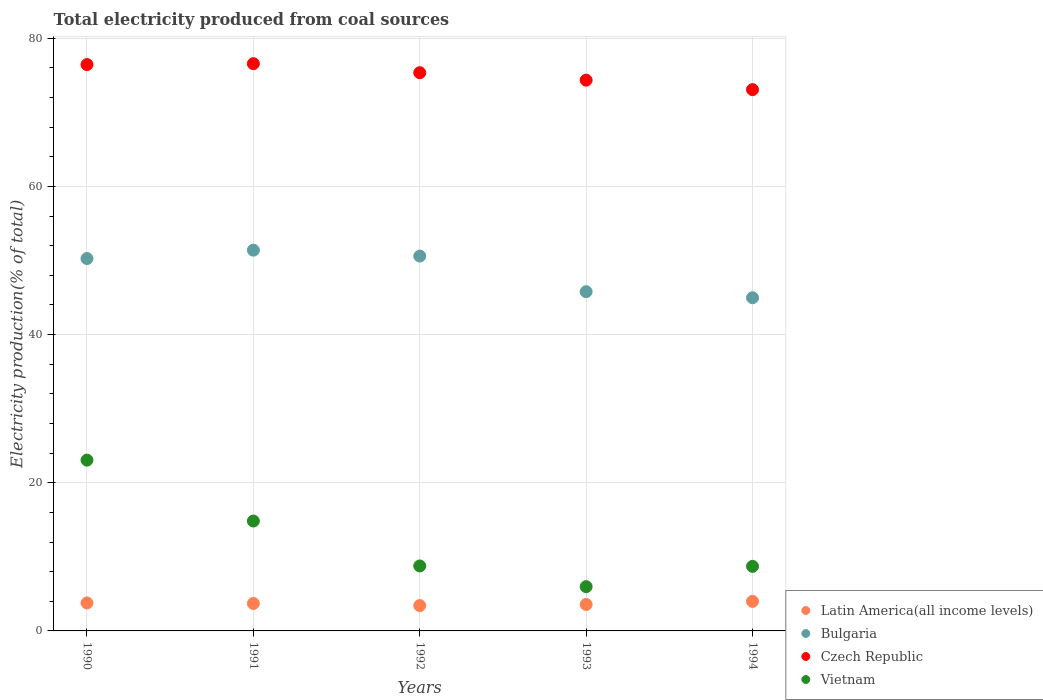What is the total electricity produced in Bulgaria in 1991?
Offer a very short reply. 51.39. Across all years, what is the maximum total electricity produced in Latin America(all income levels)?
Make the answer very short. 3.99. Across all years, what is the minimum total electricity produced in Bulgaria?
Provide a succinct answer. 44.97. In which year was the total electricity produced in Latin America(all income levels) maximum?
Provide a succinct answer. 1994. In which year was the total electricity produced in Bulgaria minimum?
Make the answer very short. 1994. What is the total total electricity produced in Vietnam in the graph?
Give a very brief answer. 61.34. What is the difference between the total electricity produced in Bulgaria in 1990 and that in 1993?
Your response must be concise. 4.47. What is the difference between the total electricity produced in Latin America(all income levels) in 1994 and the total electricity produced in Czech Republic in 1992?
Your answer should be very brief. -71.35. What is the average total electricity produced in Latin America(all income levels) per year?
Your response must be concise. 3.69. In the year 1993, what is the difference between the total electricity produced in Latin America(all income levels) and total electricity produced in Czech Republic?
Keep it short and to the point. -70.77. What is the ratio of the total electricity produced in Latin America(all income levels) in 1990 to that in 1991?
Offer a terse response. 1.02. Is the total electricity produced in Latin America(all income levels) in 1993 less than that in 1994?
Make the answer very short. Yes. Is the difference between the total electricity produced in Latin America(all income levels) in 1990 and 1991 greater than the difference between the total electricity produced in Czech Republic in 1990 and 1991?
Ensure brevity in your answer.  Yes. What is the difference between the highest and the second highest total electricity produced in Vietnam?
Provide a succinct answer. 8.22. What is the difference between the highest and the lowest total electricity produced in Czech Republic?
Offer a terse response. 3.5. Is the sum of the total electricity produced in Bulgaria in 1990 and 1991 greater than the maximum total electricity produced in Latin America(all income levels) across all years?
Offer a very short reply. Yes. How many years are there in the graph?
Your answer should be very brief. 5. Are the values on the major ticks of Y-axis written in scientific E-notation?
Provide a succinct answer. No. What is the title of the graph?
Your answer should be very brief. Total electricity produced from coal sources. What is the label or title of the X-axis?
Provide a succinct answer. Years. What is the label or title of the Y-axis?
Provide a short and direct response. Electricity production(% of total). What is the Electricity production(% of total) in Latin America(all income levels) in 1990?
Provide a succinct answer. 3.78. What is the Electricity production(% of total) in Bulgaria in 1990?
Keep it short and to the point. 50.26. What is the Electricity production(% of total) in Czech Republic in 1990?
Make the answer very short. 76.44. What is the Electricity production(% of total) in Vietnam in 1990?
Your answer should be compact. 23.05. What is the Electricity production(% of total) in Latin America(all income levels) in 1991?
Offer a terse response. 3.7. What is the Electricity production(% of total) of Bulgaria in 1991?
Your response must be concise. 51.39. What is the Electricity production(% of total) of Czech Republic in 1991?
Provide a short and direct response. 76.56. What is the Electricity production(% of total) in Vietnam in 1991?
Offer a terse response. 14.83. What is the Electricity production(% of total) in Latin America(all income levels) in 1992?
Give a very brief answer. 3.42. What is the Electricity production(% of total) in Bulgaria in 1992?
Give a very brief answer. 50.59. What is the Electricity production(% of total) in Czech Republic in 1992?
Your answer should be compact. 75.34. What is the Electricity production(% of total) in Vietnam in 1992?
Make the answer very short. 8.77. What is the Electricity production(% of total) of Latin America(all income levels) in 1993?
Provide a succinct answer. 3.57. What is the Electricity production(% of total) in Bulgaria in 1993?
Your answer should be very brief. 45.79. What is the Electricity production(% of total) in Czech Republic in 1993?
Provide a short and direct response. 74.34. What is the Electricity production(% of total) in Vietnam in 1993?
Offer a very short reply. 5.97. What is the Electricity production(% of total) of Latin America(all income levels) in 1994?
Your answer should be compact. 3.99. What is the Electricity production(% of total) of Bulgaria in 1994?
Your response must be concise. 44.97. What is the Electricity production(% of total) of Czech Republic in 1994?
Your answer should be very brief. 73.06. What is the Electricity production(% of total) of Vietnam in 1994?
Keep it short and to the point. 8.72. Across all years, what is the maximum Electricity production(% of total) of Latin America(all income levels)?
Offer a very short reply. 3.99. Across all years, what is the maximum Electricity production(% of total) of Bulgaria?
Ensure brevity in your answer.  51.39. Across all years, what is the maximum Electricity production(% of total) in Czech Republic?
Provide a short and direct response. 76.56. Across all years, what is the maximum Electricity production(% of total) in Vietnam?
Keep it short and to the point. 23.05. Across all years, what is the minimum Electricity production(% of total) in Latin America(all income levels)?
Offer a very short reply. 3.42. Across all years, what is the minimum Electricity production(% of total) in Bulgaria?
Ensure brevity in your answer.  44.97. Across all years, what is the minimum Electricity production(% of total) of Czech Republic?
Ensure brevity in your answer.  73.06. Across all years, what is the minimum Electricity production(% of total) of Vietnam?
Ensure brevity in your answer.  5.97. What is the total Electricity production(% of total) of Latin America(all income levels) in the graph?
Your answer should be very brief. 18.46. What is the total Electricity production(% of total) in Bulgaria in the graph?
Offer a terse response. 243. What is the total Electricity production(% of total) in Czech Republic in the graph?
Keep it short and to the point. 375.74. What is the total Electricity production(% of total) of Vietnam in the graph?
Offer a terse response. 61.34. What is the difference between the Electricity production(% of total) in Latin America(all income levels) in 1990 and that in 1991?
Provide a succinct answer. 0.07. What is the difference between the Electricity production(% of total) of Bulgaria in 1990 and that in 1991?
Your answer should be very brief. -1.13. What is the difference between the Electricity production(% of total) in Czech Republic in 1990 and that in 1991?
Your response must be concise. -0.12. What is the difference between the Electricity production(% of total) of Vietnam in 1990 and that in 1991?
Provide a short and direct response. 8.22. What is the difference between the Electricity production(% of total) of Latin America(all income levels) in 1990 and that in 1992?
Keep it short and to the point. 0.36. What is the difference between the Electricity production(% of total) of Bulgaria in 1990 and that in 1992?
Your response must be concise. -0.33. What is the difference between the Electricity production(% of total) of Czech Republic in 1990 and that in 1992?
Ensure brevity in your answer.  1.1. What is the difference between the Electricity production(% of total) of Vietnam in 1990 and that in 1992?
Your response must be concise. 14.28. What is the difference between the Electricity production(% of total) in Latin America(all income levels) in 1990 and that in 1993?
Your response must be concise. 0.2. What is the difference between the Electricity production(% of total) of Bulgaria in 1990 and that in 1993?
Keep it short and to the point. 4.47. What is the difference between the Electricity production(% of total) of Czech Republic in 1990 and that in 1993?
Keep it short and to the point. 2.1. What is the difference between the Electricity production(% of total) of Vietnam in 1990 and that in 1993?
Provide a succinct answer. 17.08. What is the difference between the Electricity production(% of total) of Latin America(all income levels) in 1990 and that in 1994?
Your answer should be very brief. -0.21. What is the difference between the Electricity production(% of total) of Bulgaria in 1990 and that in 1994?
Make the answer very short. 5.29. What is the difference between the Electricity production(% of total) of Czech Republic in 1990 and that in 1994?
Give a very brief answer. 3.38. What is the difference between the Electricity production(% of total) of Vietnam in 1990 and that in 1994?
Make the answer very short. 14.33. What is the difference between the Electricity production(% of total) in Latin America(all income levels) in 1991 and that in 1992?
Provide a short and direct response. 0.28. What is the difference between the Electricity production(% of total) of Bulgaria in 1991 and that in 1992?
Give a very brief answer. 0.8. What is the difference between the Electricity production(% of total) of Czech Republic in 1991 and that in 1992?
Your response must be concise. 1.22. What is the difference between the Electricity production(% of total) in Vietnam in 1991 and that in 1992?
Your answer should be very brief. 6.06. What is the difference between the Electricity production(% of total) of Latin America(all income levels) in 1991 and that in 1993?
Make the answer very short. 0.13. What is the difference between the Electricity production(% of total) of Bulgaria in 1991 and that in 1993?
Provide a succinct answer. 5.6. What is the difference between the Electricity production(% of total) in Czech Republic in 1991 and that in 1993?
Your answer should be very brief. 2.22. What is the difference between the Electricity production(% of total) of Vietnam in 1991 and that in 1993?
Your answer should be very brief. 8.86. What is the difference between the Electricity production(% of total) in Latin America(all income levels) in 1991 and that in 1994?
Provide a succinct answer. -0.29. What is the difference between the Electricity production(% of total) of Bulgaria in 1991 and that in 1994?
Give a very brief answer. 6.42. What is the difference between the Electricity production(% of total) of Czech Republic in 1991 and that in 1994?
Give a very brief answer. 3.5. What is the difference between the Electricity production(% of total) in Vietnam in 1991 and that in 1994?
Your response must be concise. 6.12. What is the difference between the Electricity production(% of total) of Latin America(all income levels) in 1992 and that in 1993?
Your response must be concise. -0.15. What is the difference between the Electricity production(% of total) of Bulgaria in 1992 and that in 1993?
Ensure brevity in your answer.  4.8. What is the difference between the Electricity production(% of total) of Czech Republic in 1992 and that in 1993?
Give a very brief answer. 1. What is the difference between the Electricity production(% of total) in Vietnam in 1992 and that in 1993?
Provide a succinct answer. 2.79. What is the difference between the Electricity production(% of total) in Latin America(all income levels) in 1992 and that in 1994?
Ensure brevity in your answer.  -0.57. What is the difference between the Electricity production(% of total) in Bulgaria in 1992 and that in 1994?
Make the answer very short. 5.62. What is the difference between the Electricity production(% of total) in Czech Republic in 1992 and that in 1994?
Give a very brief answer. 2.28. What is the difference between the Electricity production(% of total) of Vietnam in 1992 and that in 1994?
Give a very brief answer. 0.05. What is the difference between the Electricity production(% of total) of Latin America(all income levels) in 1993 and that in 1994?
Make the answer very short. -0.42. What is the difference between the Electricity production(% of total) in Bulgaria in 1993 and that in 1994?
Provide a short and direct response. 0.82. What is the difference between the Electricity production(% of total) in Czech Republic in 1993 and that in 1994?
Make the answer very short. 1.28. What is the difference between the Electricity production(% of total) in Vietnam in 1993 and that in 1994?
Offer a very short reply. -2.74. What is the difference between the Electricity production(% of total) of Latin America(all income levels) in 1990 and the Electricity production(% of total) of Bulgaria in 1991?
Provide a short and direct response. -47.62. What is the difference between the Electricity production(% of total) of Latin America(all income levels) in 1990 and the Electricity production(% of total) of Czech Republic in 1991?
Offer a terse response. -72.79. What is the difference between the Electricity production(% of total) in Latin America(all income levels) in 1990 and the Electricity production(% of total) in Vietnam in 1991?
Offer a terse response. -11.06. What is the difference between the Electricity production(% of total) in Bulgaria in 1990 and the Electricity production(% of total) in Czech Republic in 1991?
Offer a terse response. -26.3. What is the difference between the Electricity production(% of total) in Bulgaria in 1990 and the Electricity production(% of total) in Vietnam in 1991?
Provide a succinct answer. 35.43. What is the difference between the Electricity production(% of total) in Czech Republic in 1990 and the Electricity production(% of total) in Vietnam in 1991?
Your response must be concise. 61.61. What is the difference between the Electricity production(% of total) in Latin America(all income levels) in 1990 and the Electricity production(% of total) in Bulgaria in 1992?
Keep it short and to the point. -46.82. What is the difference between the Electricity production(% of total) of Latin America(all income levels) in 1990 and the Electricity production(% of total) of Czech Republic in 1992?
Your answer should be compact. -71.56. What is the difference between the Electricity production(% of total) of Latin America(all income levels) in 1990 and the Electricity production(% of total) of Vietnam in 1992?
Provide a succinct answer. -4.99. What is the difference between the Electricity production(% of total) in Bulgaria in 1990 and the Electricity production(% of total) in Czech Republic in 1992?
Your answer should be compact. -25.08. What is the difference between the Electricity production(% of total) in Bulgaria in 1990 and the Electricity production(% of total) in Vietnam in 1992?
Your answer should be compact. 41.49. What is the difference between the Electricity production(% of total) in Czech Republic in 1990 and the Electricity production(% of total) in Vietnam in 1992?
Make the answer very short. 67.67. What is the difference between the Electricity production(% of total) of Latin America(all income levels) in 1990 and the Electricity production(% of total) of Bulgaria in 1993?
Offer a terse response. -42.01. What is the difference between the Electricity production(% of total) in Latin America(all income levels) in 1990 and the Electricity production(% of total) in Czech Republic in 1993?
Make the answer very short. -70.56. What is the difference between the Electricity production(% of total) in Latin America(all income levels) in 1990 and the Electricity production(% of total) in Vietnam in 1993?
Keep it short and to the point. -2.2. What is the difference between the Electricity production(% of total) in Bulgaria in 1990 and the Electricity production(% of total) in Czech Republic in 1993?
Your answer should be compact. -24.08. What is the difference between the Electricity production(% of total) in Bulgaria in 1990 and the Electricity production(% of total) in Vietnam in 1993?
Make the answer very short. 44.29. What is the difference between the Electricity production(% of total) of Czech Republic in 1990 and the Electricity production(% of total) of Vietnam in 1993?
Ensure brevity in your answer.  70.47. What is the difference between the Electricity production(% of total) of Latin America(all income levels) in 1990 and the Electricity production(% of total) of Bulgaria in 1994?
Offer a very short reply. -41.19. What is the difference between the Electricity production(% of total) of Latin America(all income levels) in 1990 and the Electricity production(% of total) of Czech Republic in 1994?
Give a very brief answer. -69.28. What is the difference between the Electricity production(% of total) in Latin America(all income levels) in 1990 and the Electricity production(% of total) in Vietnam in 1994?
Your answer should be compact. -4.94. What is the difference between the Electricity production(% of total) of Bulgaria in 1990 and the Electricity production(% of total) of Czech Republic in 1994?
Offer a very short reply. -22.8. What is the difference between the Electricity production(% of total) in Bulgaria in 1990 and the Electricity production(% of total) in Vietnam in 1994?
Make the answer very short. 41.54. What is the difference between the Electricity production(% of total) of Czech Republic in 1990 and the Electricity production(% of total) of Vietnam in 1994?
Your response must be concise. 67.72. What is the difference between the Electricity production(% of total) of Latin America(all income levels) in 1991 and the Electricity production(% of total) of Bulgaria in 1992?
Your response must be concise. -46.89. What is the difference between the Electricity production(% of total) of Latin America(all income levels) in 1991 and the Electricity production(% of total) of Czech Republic in 1992?
Give a very brief answer. -71.64. What is the difference between the Electricity production(% of total) in Latin America(all income levels) in 1991 and the Electricity production(% of total) in Vietnam in 1992?
Provide a short and direct response. -5.07. What is the difference between the Electricity production(% of total) in Bulgaria in 1991 and the Electricity production(% of total) in Czech Republic in 1992?
Offer a very short reply. -23.95. What is the difference between the Electricity production(% of total) of Bulgaria in 1991 and the Electricity production(% of total) of Vietnam in 1992?
Offer a very short reply. 42.62. What is the difference between the Electricity production(% of total) in Czech Republic in 1991 and the Electricity production(% of total) in Vietnam in 1992?
Offer a very short reply. 67.79. What is the difference between the Electricity production(% of total) in Latin America(all income levels) in 1991 and the Electricity production(% of total) in Bulgaria in 1993?
Make the answer very short. -42.09. What is the difference between the Electricity production(% of total) in Latin America(all income levels) in 1991 and the Electricity production(% of total) in Czech Republic in 1993?
Your answer should be very brief. -70.64. What is the difference between the Electricity production(% of total) in Latin America(all income levels) in 1991 and the Electricity production(% of total) in Vietnam in 1993?
Your response must be concise. -2.27. What is the difference between the Electricity production(% of total) of Bulgaria in 1991 and the Electricity production(% of total) of Czech Republic in 1993?
Keep it short and to the point. -22.95. What is the difference between the Electricity production(% of total) of Bulgaria in 1991 and the Electricity production(% of total) of Vietnam in 1993?
Keep it short and to the point. 45.42. What is the difference between the Electricity production(% of total) of Czech Republic in 1991 and the Electricity production(% of total) of Vietnam in 1993?
Offer a terse response. 70.59. What is the difference between the Electricity production(% of total) in Latin America(all income levels) in 1991 and the Electricity production(% of total) in Bulgaria in 1994?
Offer a very short reply. -41.27. What is the difference between the Electricity production(% of total) in Latin America(all income levels) in 1991 and the Electricity production(% of total) in Czech Republic in 1994?
Your answer should be compact. -69.35. What is the difference between the Electricity production(% of total) of Latin America(all income levels) in 1991 and the Electricity production(% of total) of Vietnam in 1994?
Keep it short and to the point. -5.01. What is the difference between the Electricity production(% of total) in Bulgaria in 1991 and the Electricity production(% of total) in Czech Republic in 1994?
Make the answer very short. -21.66. What is the difference between the Electricity production(% of total) of Bulgaria in 1991 and the Electricity production(% of total) of Vietnam in 1994?
Your answer should be compact. 42.68. What is the difference between the Electricity production(% of total) in Czech Republic in 1991 and the Electricity production(% of total) in Vietnam in 1994?
Your response must be concise. 67.85. What is the difference between the Electricity production(% of total) of Latin America(all income levels) in 1992 and the Electricity production(% of total) of Bulgaria in 1993?
Your answer should be compact. -42.37. What is the difference between the Electricity production(% of total) in Latin America(all income levels) in 1992 and the Electricity production(% of total) in Czech Republic in 1993?
Provide a short and direct response. -70.92. What is the difference between the Electricity production(% of total) in Latin America(all income levels) in 1992 and the Electricity production(% of total) in Vietnam in 1993?
Provide a succinct answer. -2.55. What is the difference between the Electricity production(% of total) of Bulgaria in 1992 and the Electricity production(% of total) of Czech Republic in 1993?
Provide a succinct answer. -23.75. What is the difference between the Electricity production(% of total) in Bulgaria in 1992 and the Electricity production(% of total) in Vietnam in 1993?
Keep it short and to the point. 44.62. What is the difference between the Electricity production(% of total) in Czech Republic in 1992 and the Electricity production(% of total) in Vietnam in 1993?
Make the answer very short. 69.37. What is the difference between the Electricity production(% of total) in Latin America(all income levels) in 1992 and the Electricity production(% of total) in Bulgaria in 1994?
Offer a terse response. -41.55. What is the difference between the Electricity production(% of total) in Latin America(all income levels) in 1992 and the Electricity production(% of total) in Czech Republic in 1994?
Give a very brief answer. -69.64. What is the difference between the Electricity production(% of total) of Latin America(all income levels) in 1992 and the Electricity production(% of total) of Vietnam in 1994?
Keep it short and to the point. -5.29. What is the difference between the Electricity production(% of total) in Bulgaria in 1992 and the Electricity production(% of total) in Czech Republic in 1994?
Make the answer very short. -22.46. What is the difference between the Electricity production(% of total) in Bulgaria in 1992 and the Electricity production(% of total) in Vietnam in 1994?
Give a very brief answer. 41.88. What is the difference between the Electricity production(% of total) in Czech Republic in 1992 and the Electricity production(% of total) in Vietnam in 1994?
Offer a very short reply. 66.62. What is the difference between the Electricity production(% of total) in Latin America(all income levels) in 1993 and the Electricity production(% of total) in Bulgaria in 1994?
Your answer should be compact. -41.4. What is the difference between the Electricity production(% of total) of Latin America(all income levels) in 1993 and the Electricity production(% of total) of Czech Republic in 1994?
Your answer should be very brief. -69.48. What is the difference between the Electricity production(% of total) of Latin America(all income levels) in 1993 and the Electricity production(% of total) of Vietnam in 1994?
Provide a short and direct response. -5.14. What is the difference between the Electricity production(% of total) of Bulgaria in 1993 and the Electricity production(% of total) of Czech Republic in 1994?
Offer a very short reply. -27.27. What is the difference between the Electricity production(% of total) of Bulgaria in 1993 and the Electricity production(% of total) of Vietnam in 1994?
Your answer should be compact. 37.07. What is the difference between the Electricity production(% of total) in Czech Republic in 1993 and the Electricity production(% of total) in Vietnam in 1994?
Your response must be concise. 65.62. What is the average Electricity production(% of total) of Latin America(all income levels) per year?
Provide a short and direct response. 3.69. What is the average Electricity production(% of total) of Bulgaria per year?
Make the answer very short. 48.6. What is the average Electricity production(% of total) in Czech Republic per year?
Your answer should be compact. 75.15. What is the average Electricity production(% of total) in Vietnam per year?
Ensure brevity in your answer.  12.27. In the year 1990, what is the difference between the Electricity production(% of total) in Latin America(all income levels) and Electricity production(% of total) in Bulgaria?
Give a very brief answer. -46.48. In the year 1990, what is the difference between the Electricity production(% of total) in Latin America(all income levels) and Electricity production(% of total) in Czech Republic?
Your answer should be compact. -72.66. In the year 1990, what is the difference between the Electricity production(% of total) in Latin America(all income levels) and Electricity production(% of total) in Vietnam?
Offer a very short reply. -19.27. In the year 1990, what is the difference between the Electricity production(% of total) of Bulgaria and Electricity production(% of total) of Czech Republic?
Provide a short and direct response. -26.18. In the year 1990, what is the difference between the Electricity production(% of total) of Bulgaria and Electricity production(% of total) of Vietnam?
Give a very brief answer. 27.21. In the year 1990, what is the difference between the Electricity production(% of total) of Czech Republic and Electricity production(% of total) of Vietnam?
Your answer should be compact. 53.39. In the year 1991, what is the difference between the Electricity production(% of total) in Latin America(all income levels) and Electricity production(% of total) in Bulgaria?
Offer a terse response. -47.69. In the year 1991, what is the difference between the Electricity production(% of total) of Latin America(all income levels) and Electricity production(% of total) of Czech Republic?
Ensure brevity in your answer.  -72.86. In the year 1991, what is the difference between the Electricity production(% of total) in Latin America(all income levels) and Electricity production(% of total) in Vietnam?
Your answer should be compact. -11.13. In the year 1991, what is the difference between the Electricity production(% of total) of Bulgaria and Electricity production(% of total) of Czech Republic?
Offer a terse response. -25.17. In the year 1991, what is the difference between the Electricity production(% of total) of Bulgaria and Electricity production(% of total) of Vietnam?
Provide a succinct answer. 36.56. In the year 1991, what is the difference between the Electricity production(% of total) of Czech Republic and Electricity production(% of total) of Vietnam?
Give a very brief answer. 61.73. In the year 1992, what is the difference between the Electricity production(% of total) in Latin America(all income levels) and Electricity production(% of total) in Bulgaria?
Give a very brief answer. -47.17. In the year 1992, what is the difference between the Electricity production(% of total) in Latin America(all income levels) and Electricity production(% of total) in Czech Republic?
Your answer should be very brief. -71.92. In the year 1992, what is the difference between the Electricity production(% of total) of Latin America(all income levels) and Electricity production(% of total) of Vietnam?
Give a very brief answer. -5.35. In the year 1992, what is the difference between the Electricity production(% of total) in Bulgaria and Electricity production(% of total) in Czech Republic?
Keep it short and to the point. -24.75. In the year 1992, what is the difference between the Electricity production(% of total) of Bulgaria and Electricity production(% of total) of Vietnam?
Offer a very short reply. 41.82. In the year 1992, what is the difference between the Electricity production(% of total) in Czech Republic and Electricity production(% of total) in Vietnam?
Your answer should be compact. 66.57. In the year 1993, what is the difference between the Electricity production(% of total) in Latin America(all income levels) and Electricity production(% of total) in Bulgaria?
Provide a short and direct response. -42.22. In the year 1993, what is the difference between the Electricity production(% of total) in Latin America(all income levels) and Electricity production(% of total) in Czech Republic?
Provide a succinct answer. -70.77. In the year 1993, what is the difference between the Electricity production(% of total) of Latin America(all income levels) and Electricity production(% of total) of Vietnam?
Your answer should be very brief. -2.4. In the year 1993, what is the difference between the Electricity production(% of total) of Bulgaria and Electricity production(% of total) of Czech Republic?
Provide a short and direct response. -28.55. In the year 1993, what is the difference between the Electricity production(% of total) of Bulgaria and Electricity production(% of total) of Vietnam?
Make the answer very short. 39.81. In the year 1993, what is the difference between the Electricity production(% of total) of Czech Republic and Electricity production(% of total) of Vietnam?
Give a very brief answer. 68.36. In the year 1994, what is the difference between the Electricity production(% of total) of Latin America(all income levels) and Electricity production(% of total) of Bulgaria?
Your answer should be compact. -40.98. In the year 1994, what is the difference between the Electricity production(% of total) of Latin America(all income levels) and Electricity production(% of total) of Czech Republic?
Make the answer very short. -69.07. In the year 1994, what is the difference between the Electricity production(% of total) of Latin America(all income levels) and Electricity production(% of total) of Vietnam?
Provide a succinct answer. -4.73. In the year 1994, what is the difference between the Electricity production(% of total) in Bulgaria and Electricity production(% of total) in Czech Republic?
Make the answer very short. -28.09. In the year 1994, what is the difference between the Electricity production(% of total) of Bulgaria and Electricity production(% of total) of Vietnam?
Your answer should be compact. 36.25. In the year 1994, what is the difference between the Electricity production(% of total) in Czech Republic and Electricity production(% of total) in Vietnam?
Make the answer very short. 64.34. What is the ratio of the Electricity production(% of total) in Latin America(all income levels) in 1990 to that in 1991?
Your response must be concise. 1.02. What is the ratio of the Electricity production(% of total) in Bulgaria in 1990 to that in 1991?
Give a very brief answer. 0.98. What is the ratio of the Electricity production(% of total) of Vietnam in 1990 to that in 1991?
Keep it short and to the point. 1.55. What is the ratio of the Electricity production(% of total) in Latin America(all income levels) in 1990 to that in 1992?
Ensure brevity in your answer.  1.1. What is the ratio of the Electricity production(% of total) of Bulgaria in 1990 to that in 1992?
Offer a very short reply. 0.99. What is the ratio of the Electricity production(% of total) of Czech Republic in 1990 to that in 1992?
Offer a very short reply. 1.01. What is the ratio of the Electricity production(% of total) in Vietnam in 1990 to that in 1992?
Your response must be concise. 2.63. What is the ratio of the Electricity production(% of total) in Latin America(all income levels) in 1990 to that in 1993?
Provide a succinct answer. 1.06. What is the ratio of the Electricity production(% of total) of Bulgaria in 1990 to that in 1993?
Provide a short and direct response. 1.1. What is the ratio of the Electricity production(% of total) in Czech Republic in 1990 to that in 1993?
Keep it short and to the point. 1.03. What is the ratio of the Electricity production(% of total) in Vietnam in 1990 to that in 1993?
Your response must be concise. 3.86. What is the ratio of the Electricity production(% of total) of Latin America(all income levels) in 1990 to that in 1994?
Offer a very short reply. 0.95. What is the ratio of the Electricity production(% of total) in Bulgaria in 1990 to that in 1994?
Keep it short and to the point. 1.12. What is the ratio of the Electricity production(% of total) in Czech Republic in 1990 to that in 1994?
Give a very brief answer. 1.05. What is the ratio of the Electricity production(% of total) in Vietnam in 1990 to that in 1994?
Your answer should be compact. 2.64. What is the ratio of the Electricity production(% of total) of Latin America(all income levels) in 1991 to that in 1992?
Provide a short and direct response. 1.08. What is the ratio of the Electricity production(% of total) of Bulgaria in 1991 to that in 1992?
Offer a terse response. 1.02. What is the ratio of the Electricity production(% of total) of Czech Republic in 1991 to that in 1992?
Offer a terse response. 1.02. What is the ratio of the Electricity production(% of total) in Vietnam in 1991 to that in 1992?
Provide a succinct answer. 1.69. What is the ratio of the Electricity production(% of total) in Latin America(all income levels) in 1991 to that in 1993?
Your answer should be compact. 1.04. What is the ratio of the Electricity production(% of total) of Bulgaria in 1991 to that in 1993?
Provide a succinct answer. 1.12. What is the ratio of the Electricity production(% of total) in Czech Republic in 1991 to that in 1993?
Provide a succinct answer. 1.03. What is the ratio of the Electricity production(% of total) of Vietnam in 1991 to that in 1993?
Ensure brevity in your answer.  2.48. What is the ratio of the Electricity production(% of total) of Latin America(all income levels) in 1991 to that in 1994?
Keep it short and to the point. 0.93. What is the ratio of the Electricity production(% of total) in Bulgaria in 1991 to that in 1994?
Keep it short and to the point. 1.14. What is the ratio of the Electricity production(% of total) in Czech Republic in 1991 to that in 1994?
Your answer should be compact. 1.05. What is the ratio of the Electricity production(% of total) of Vietnam in 1991 to that in 1994?
Your answer should be very brief. 1.7. What is the ratio of the Electricity production(% of total) of Latin America(all income levels) in 1992 to that in 1993?
Ensure brevity in your answer.  0.96. What is the ratio of the Electricity production(% of total) of Bulgaria in 1992 to that in 1993?
Your answer should be compact. 1.1. What is the ratio of the Electricity production(% of total) of Czech Republic in 1992 to that in 1993?
Keep it short and to the point. 1.01. What is the ratio of the Electricity production(% of total) in Vietnam in 1992 to that in 1993?
Your answer should be very brief. 1.47. What is the ratio of the Electricity production(% of total) of Latin America(all income levels) in 1992 to that in 1994?
Give a very brief answer. 0.86. What is the ratio of the Electricity production(% of total) of Bulgaria in 1992 to that in 1994?
Offer a very short reply. 1.13. What is the ratio of the Electricity production(% of total) in Czech Republic in 1992 to that in 1994?
Keep it short and to the point. 1.03. What is the ratio of the Electricity production(% of total) of Vietnam in 1992 to that in 1994?
Offer a terse response. 1.01. What is the ratio of the Electricity production(% of total) in Latin America(all income levels) in 1993 to that in 1994?
Offer a terse response. 0.9. What is the ratio of the Electricity production(% of total) of Bulgaria in 1993 to that in 1994?
Provide a short and direct response. 1.02. What is the ratio of the Electricity production(% of total) of Czech Republic in 1993 to that in 1994?
Provide a succinct answer. 1.02. What is the ratio of the Electricity production(% of total) in Vietnam in 1993 to that in 1994?
Provide a short and direct response. 0.69. What is the difference between the highest and the second highest Electricity production(% of total) of Latin America(all income levels)?
Give a very brief answer. 0.21. What is the difference between the highest and the second highest Electricity production(% of total) in Bulgaria?
Your answer should be very brief. 0.8. What is the difference between the highest and the second highest Electricity production(% of total) of Czech Republic?
Provide a short and direct response. 0.12. What is the difference between the highest and the second highest Electricity production(% of total) in Vietnam?
Your answer should be very brief. 8.22. What is the difference between the highest and the lowest Electricity production(% of total) in Latin America(all income levels)?
Offer a very short reply. 0.57. What is the difference between the highest and the lowest Electricity production(% of total) of Bulgaria?
Keep it short and to the point. 6.42. What is the difference between the highest and the lowest Electricity production(% of total) in Czech Republic?
Offer a terse response. 3.5. What is the difference between the highest and the lowest Electricity production(% of total) of Vietnam?
Provide a succinct answer. 17.08. 